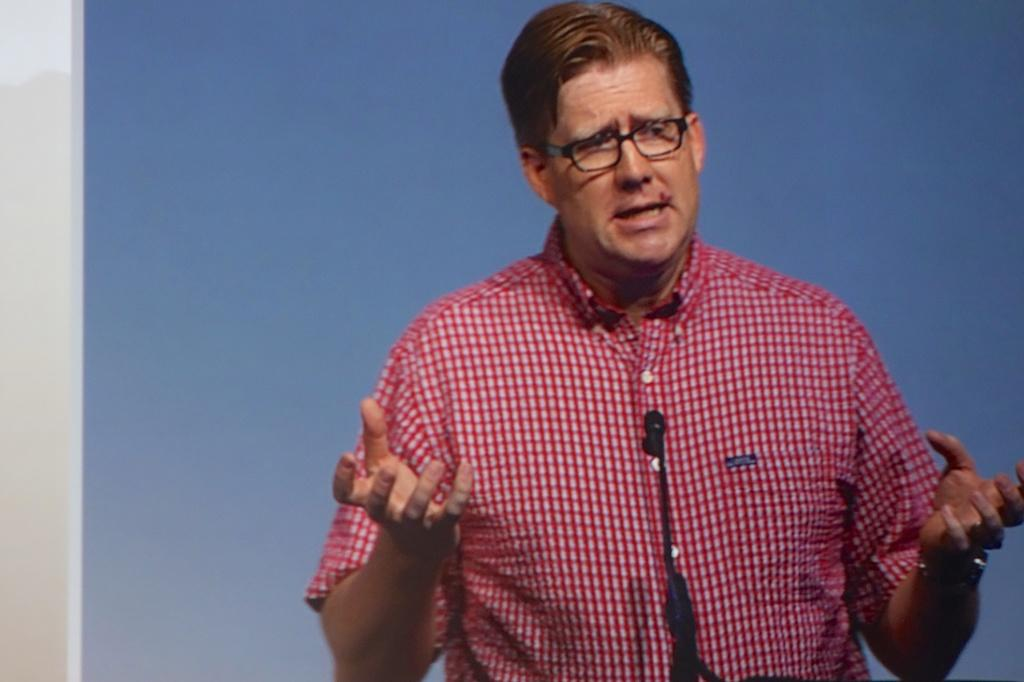What is the main subject of the image? There is a man standing in the center of the image. What is the man doing in the image? The man is speaking in the image. What object is in front of the man? There is a microphone in front of the man. What is the color of the microphone? The microphone is black in color. How many sacks can be seen in the image? There are no sacks present in the image. What is the tendency of the basketball in the image? There is no basketball present in the image, so it's not possible to determine its tendency. 